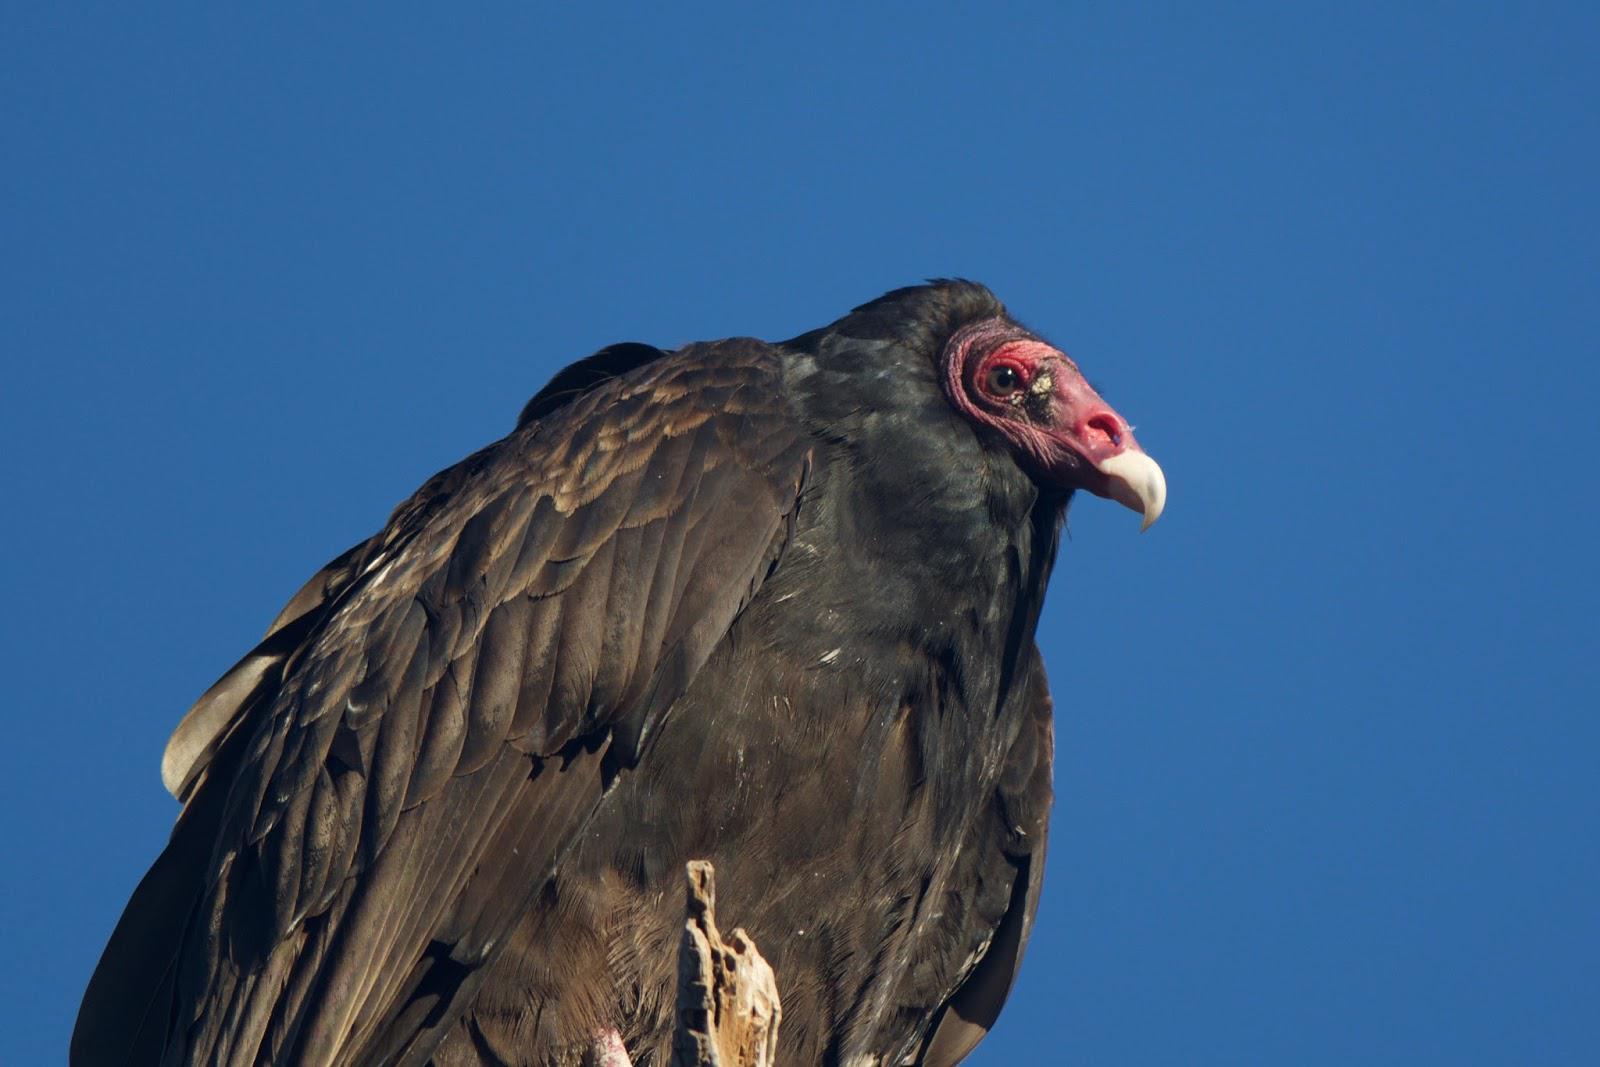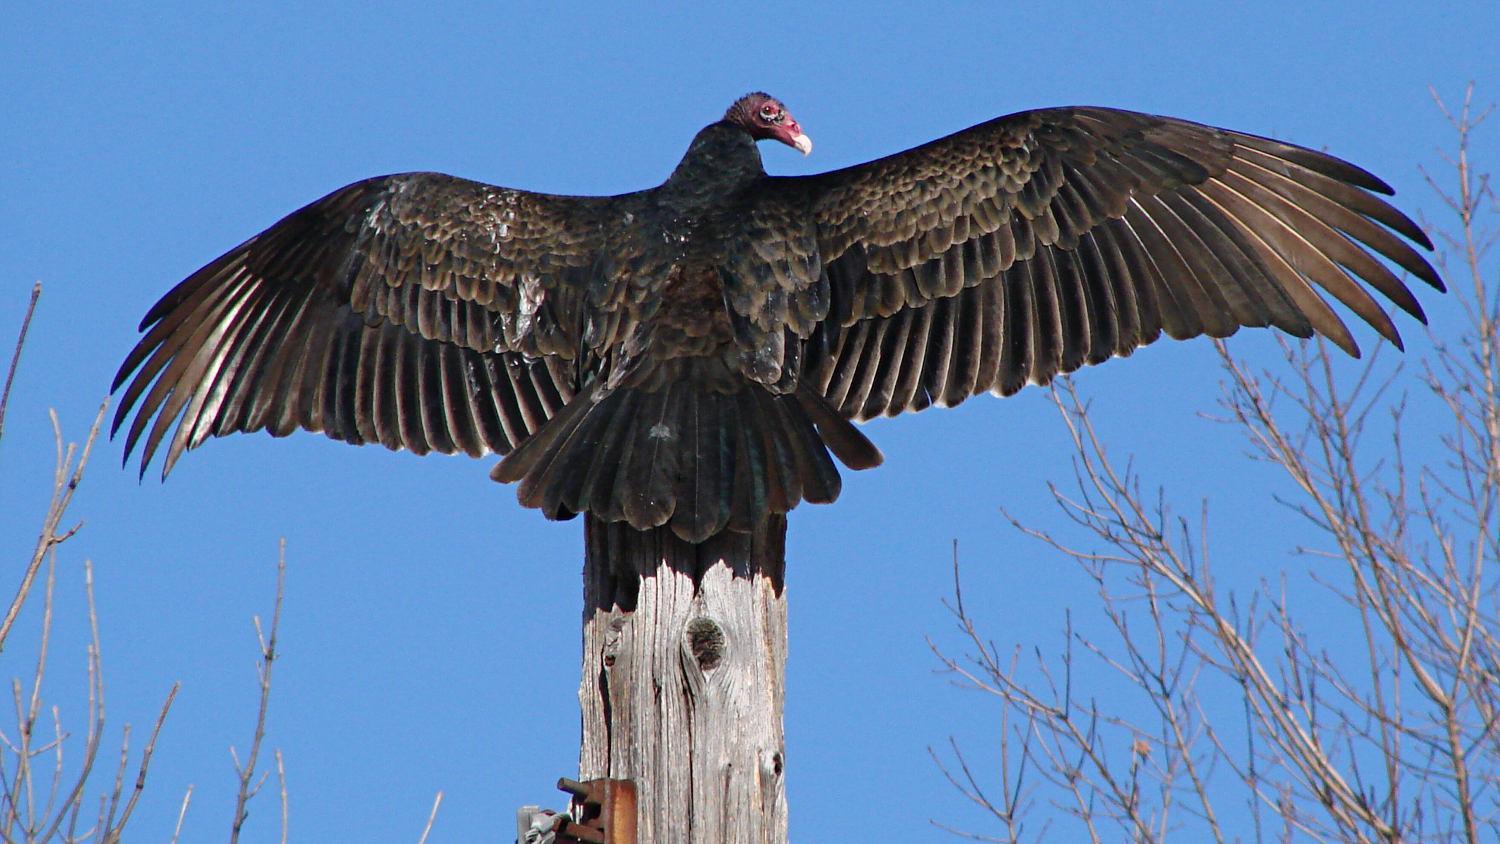The first image is the image on the left, the second image is the image on the right. Considering the images on both sides, is "In the left image, a bird is flying." valid? Answer yes or no. No. The first image is the image on the left, the second image is the image on the right. Examine the images to the left and right. Is the description "a vulture is flying with wings spread wide" accurate? Answer yes or no. No. 